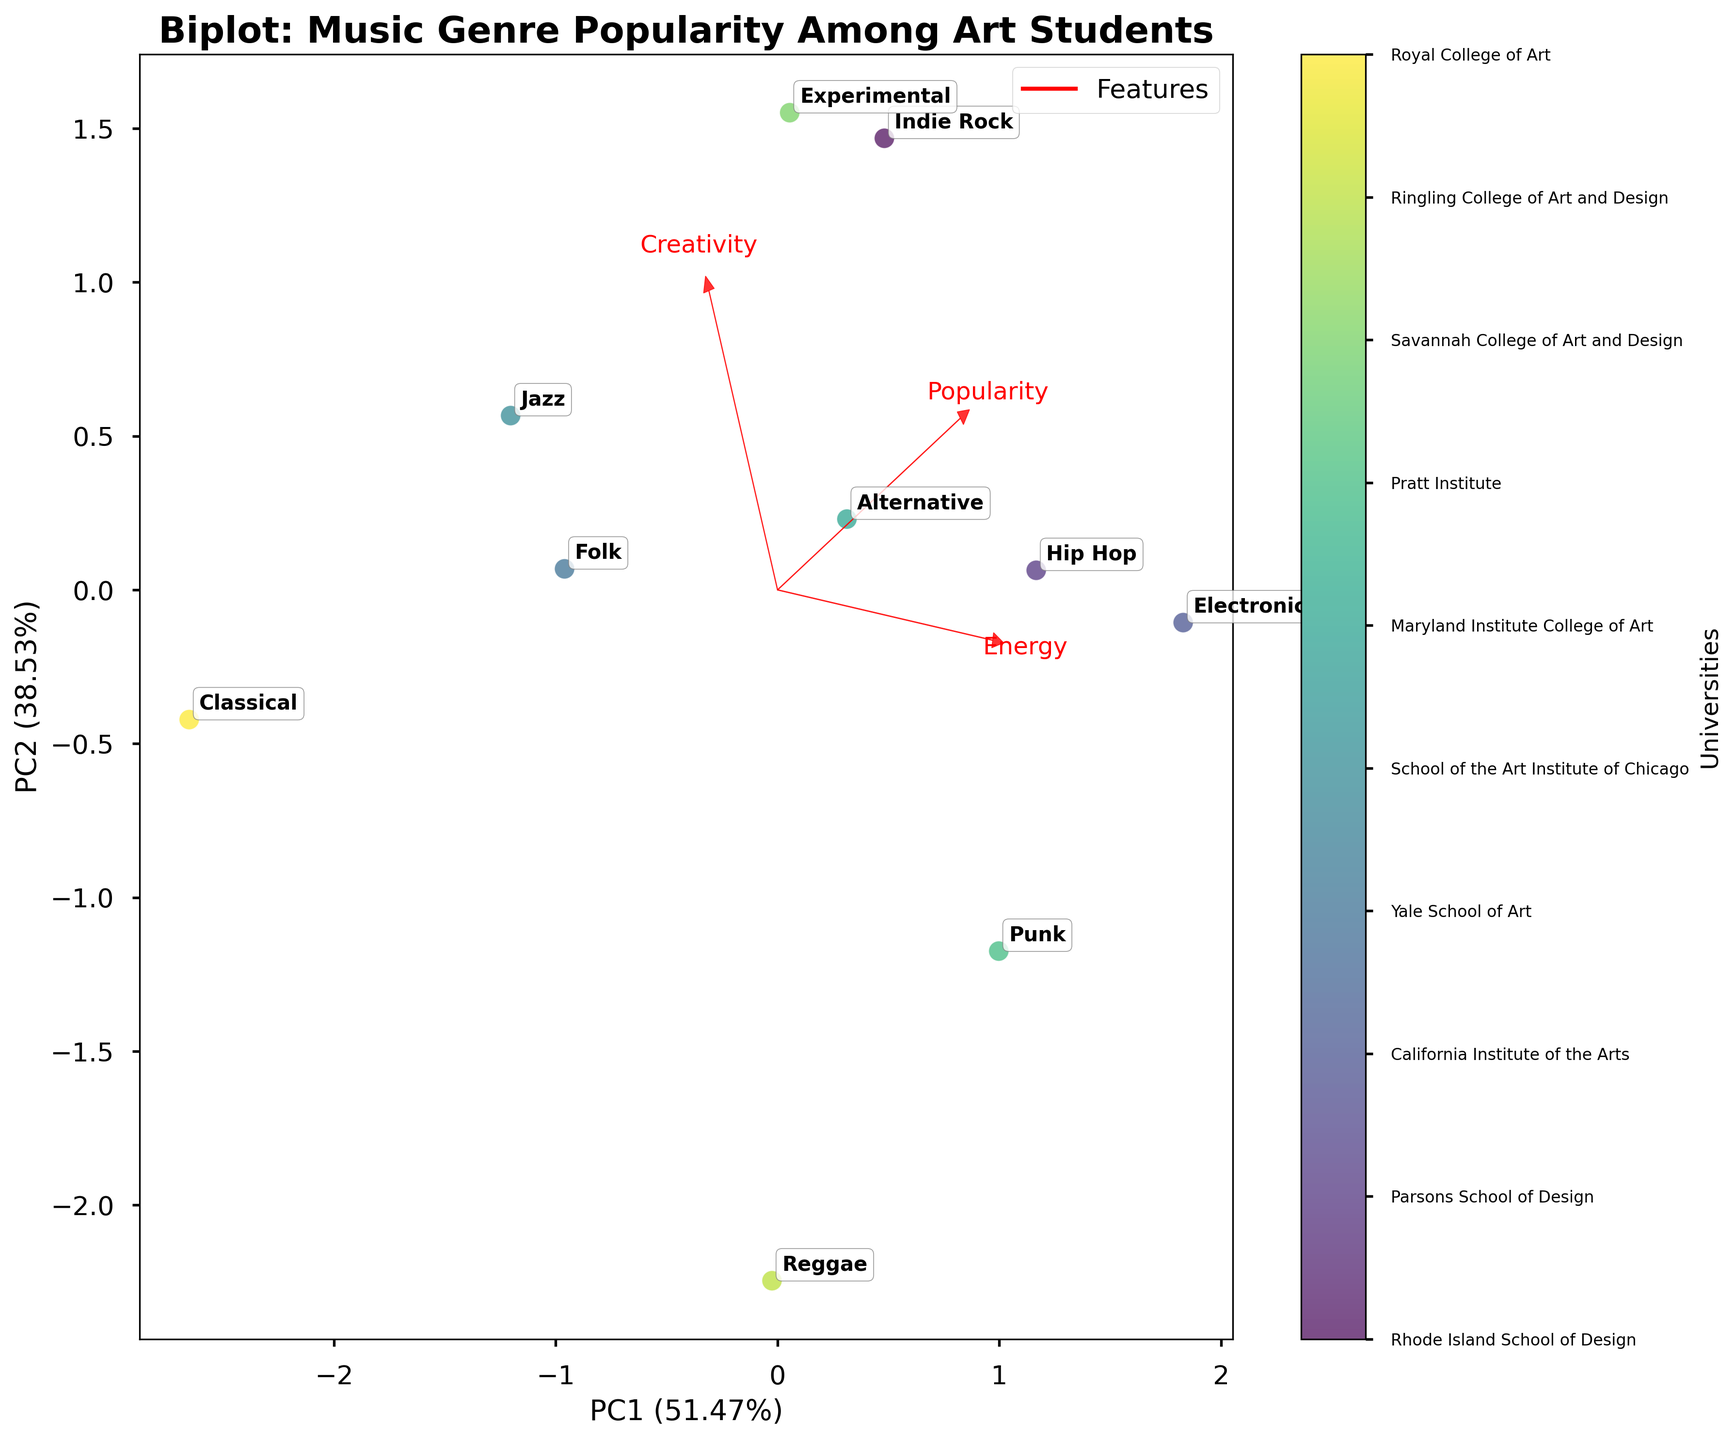What is the title of the figure? The title of the figure is usually positioned at the top and is written in a larger and bold font. In this case, it clearly states "Biplot: Music Genre Popularity Among Art Students".
Answer: Biplot: Music Genre Popularity Among Art Students Which university's genre is closest to the origin of the biplot? By observing the points on the biplot, the genre closest to the origin (0,0) can be found. In this case, it's the point with the label "Classical" from the Royal College of Art.
Answer: Royal College of Art What does the red arrow representing "Creativity" indicate? The red arrows represent the loading vectors of the principal components. The arrow labeled "Creativity" indicates the direction and magnitude of how much creativity contributes to the variation in the data. It is pointing upwards and to the right, suggesting creativity increases in that direction.
Answer: Direction and magnitude of creativity's contribution Which genres are in the same cluster or group on the biplot? Clusters or groups on a biplot are identified by points close to each other. Genres such as "Indie Rock" (Rhode Island School of Design) and "Experimental" (Savannah College of Art and Design) can be seen close together, implying they share similar characteristics.
Answer: Indie Rock and Experimental Which feature has the smallest influence based on the length of the arrows in the biplot? The length of the red arrows shows the influence of each feature. The arrow labeled "Energy" is shorter compared to "Popularity" and "Creativity", indicating that energy has the smallest influence.
Answer: Energy What percentage of the variance is explained by the first principal component (PC1)? The label of the x-axis, usually in brackets, indicates the explained variance percentage for PC1. In this case, it is stated as a percentage following "PC1".
Answer: Around 55% Which university's genre has the highest "Energy" based on the biplot? The arrow for "Energy" points in a specific direction. The data point farthest along this direction is "Hip Hop" from Parsons School of Design.
Answer: Parsons School of Design Are there any genres with low popularity and high creativity? By locating where the "Popularity" and "Creativity" arrows point, one analyzes which points fall in opposing directions. Classical music (Royal College of Art) and Folk (Yale School of Art) fit this criteria, showing low popularity and high creativity.
Answer: Classical and Folk How do "Indie Rock" and "Hip Hop" genres differ across universities in terms of loading vectors? By comparing the locations of the two genres "Indie Rock" from Rhode Island School of Design and "Hip Hop" from Parsons School of Design and examining their positions relative to the loading vectors. "Indie Rock" shows higher creativity, while "Hip Hop" is higher in energy.
Answer: Indie Rock: Higher Creativity, Hip Hop: Higher Energy 